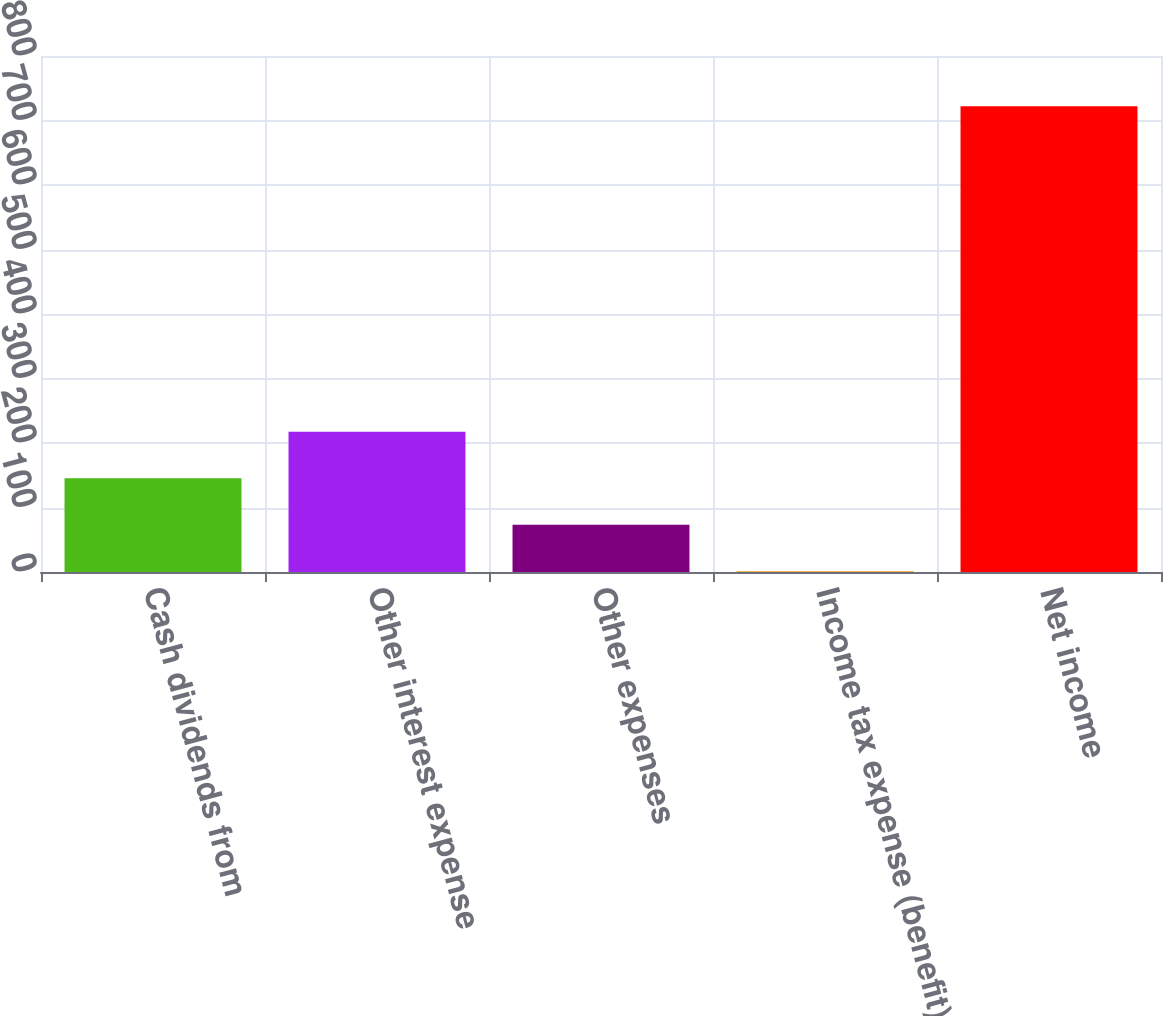Convert chart to OTSL. <chart><loc_0><loc_0><loc_500><loc_500><bar_chart><fcel>Cash dividends from<fcel>Other interest expense<fcel>Other expenses<fcel>Income tax expense (benefit)<fcel>Net income<nl><fcel>145.2<fcel>217.3<fcel>73.1<fcel>1<fcel>722<nl></chart> 